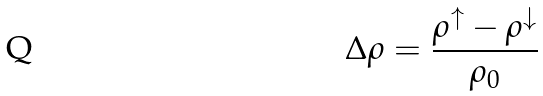Convert formula to latex. <formula><loc_0><loc_0><loc_500><loc_500>\Delta \rho = \frac { \rho ^ { \uparrow } - \rho ^ { \downarrow } } { \rho _ { 0 } }</formula> 